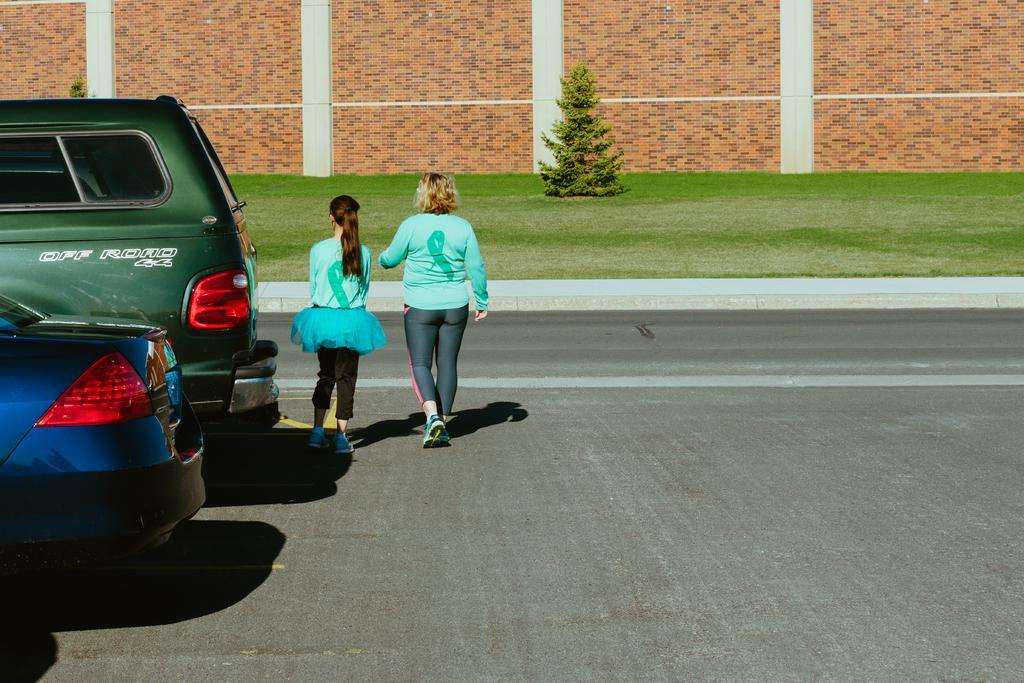Could you give a brief overview of what you see in this image? In this picture there is a woman who is standing near to the girl. Both of them are wearing green t-shirt, trouser and shoe. Both of them standing near to the cars. On the background we can see grass and trees. On the top there is a wall. On the right there is a road. 